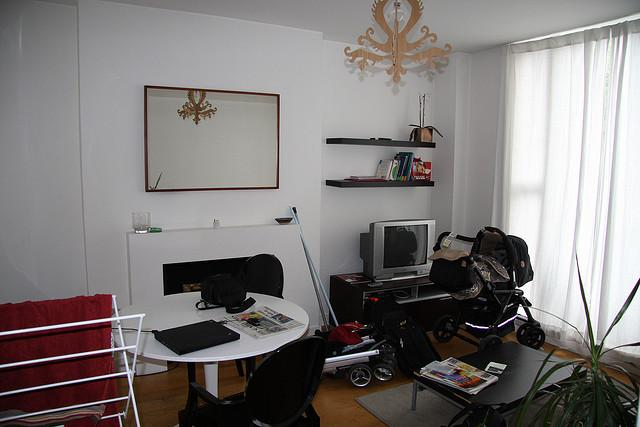Which object in the room is the most mobile? Please explain your reasoning. baby carriage. The most mobile item is going to be the one that is easiest to move. only one of the items has wheels. 